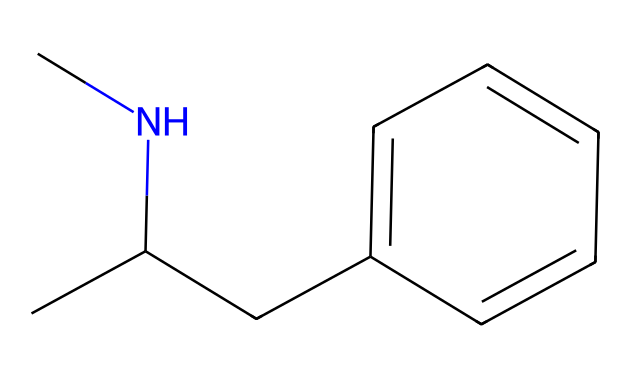What is the total number of carbon atoms in methamphetamine? In the SMILES representation, each "C" represents a carbon atom. Counting all the carbon symbols in CC(CC1=CC=CC=C1), we find 10 carbon atoms in total.
Answer: 10 How many nitrogen atoms are present in this chemical structure? The SMILES shows one "N" symbol, indicating the presence of one nitrogen atom in the molecule.
Answer: 1 What type of functional group is present in methamphetamine? The presence of the nitrogen atom bonded to carbon indicates that methamphetamine contains an amine functional group, which is characterized by the -NH group.
Answer: amine How does the molecular structure of methamphetamine influence its solubility in fats? The structure contains a hydrophobic aromatic ring and a nitrogen atom, which contributes to its lipophilic nature. Compounds with similar structures are often soluble in fats due to the presence of these non-polar regions.
Answer: lipophilic What is the role of the nitrogen in methamphetamine's pharmacological effect? The nitrogen atom allows for the molecule to interact with neurotransmitter receptors in the brain, particularly dopamine, enhancing its stimulating effects. Thus, the nitrogen is crucial for its pharmacological activity.
Answer: interacts with receptors How does the presence of the phenyl group in methamphetamine affect its stimulant properties? The phenyl group, a prominent part of the molecular structure due to the aromatic ring, contributes to the stability and bioactivity of the compound, impacting its ability to cross the blood-brain barrier and exert stimulant effects.
Answer: increases bioactivity 